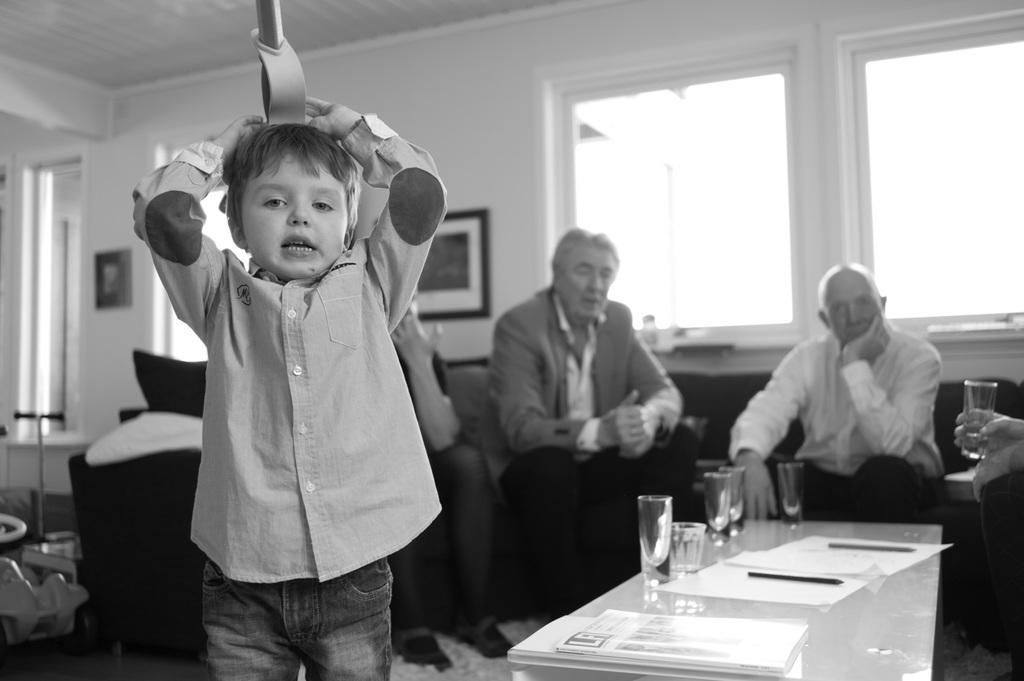How would you summarize this image in a sentence or two? In the picture we can find two men and one boy. Two men are sitting on the chairs. In front of them there is a table with some glass, papers, pens. And the boy is standing and doing some action. In the background we find a wall and windows. 